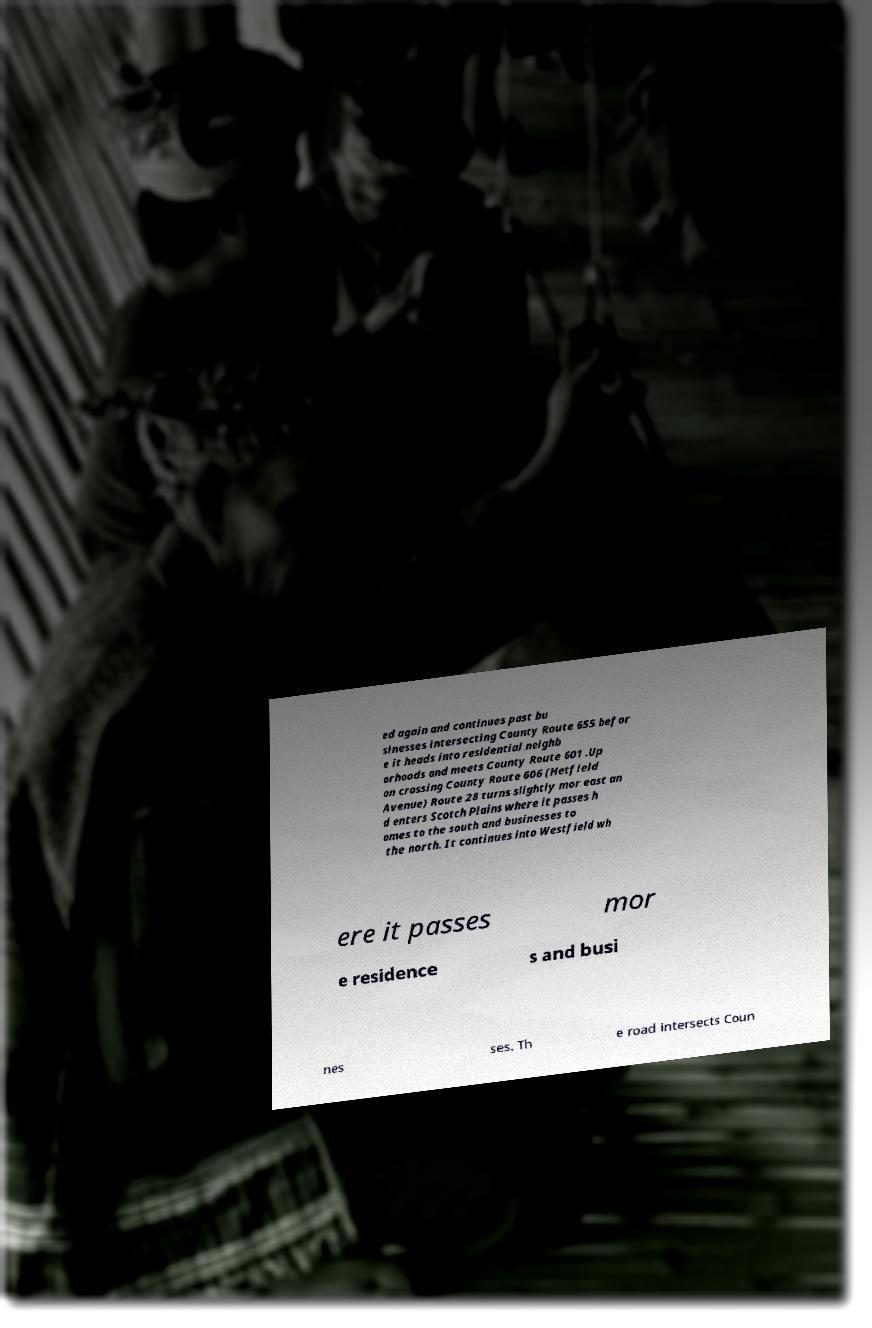Could you assist in decoding the text presented in this image and type it out clearly? ed again and continues past bu sinesses intersecting County Route 655 befor e it heads into residential neighb orhoods and meets County Route 601 .Up on crossing County Route 606 (Hetfield Avenue) Route 28 turns slightly mor east an d enters Scotch Plains where it passes h omes to the south and businesses to the north. It continues into Westfield wh ere it passes mor e residence s and busi nes ses. Th e road intersects Coun 